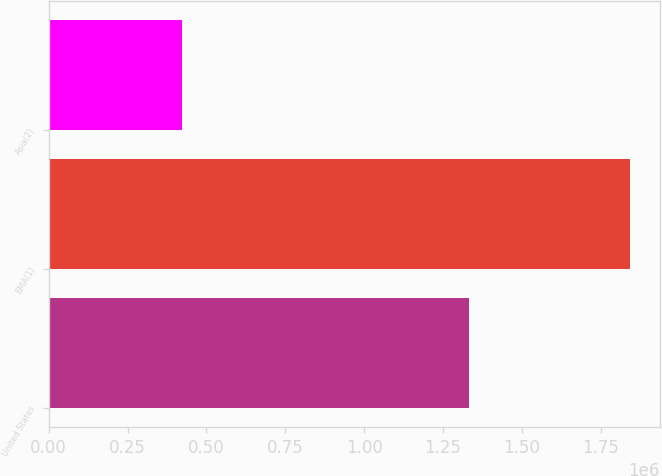<chart> <loc_0><loc_0><loc_500><loc_500><bar_chart><fcel>United States<fcel>EMA(1)<fcel>Asia(2)<nl><fcel>1.33182e+06<fcel>1.84429e+06<fcel>423461<nl></chart> 